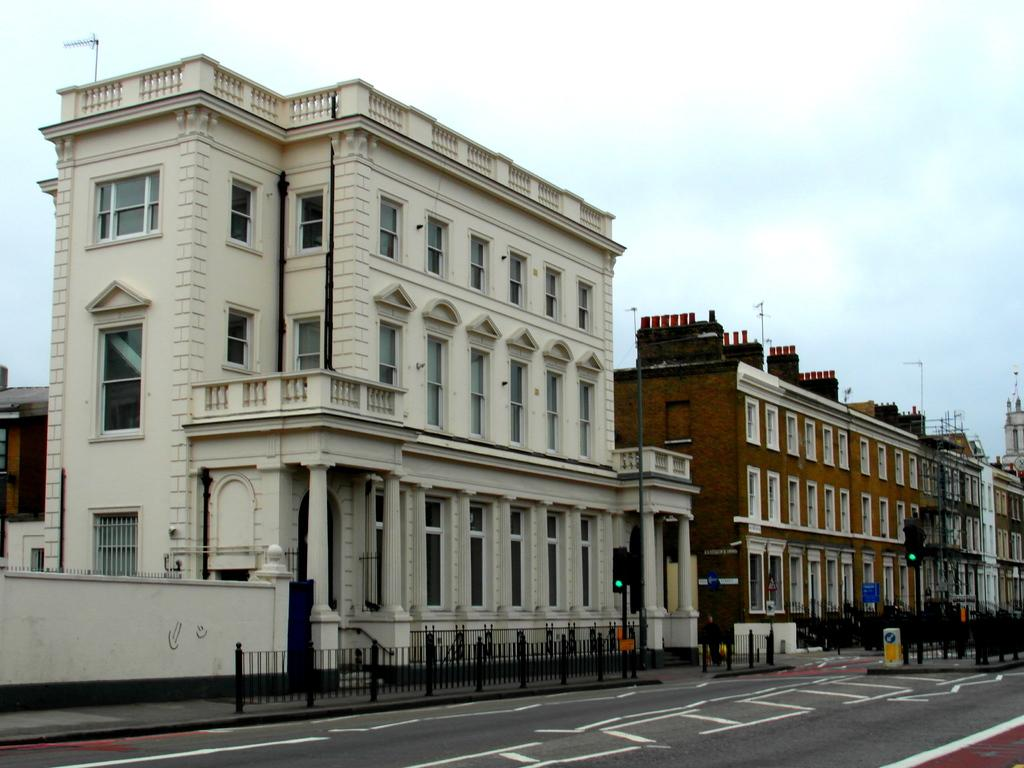What is the main feature of the image? There is a road in the image. What else can be seen alongside the road? There is a fence, traffic signal poles, boards, and buildings in the image. What is the purpose of the traffic signal poles? The traffic signal poles are used to regulate traffic flow. What can be seen in the background of the image? The sky is visible in the background of the image. Can you tell me what type of head the lawyer is wearing in the image? There is no lawyer or head present in the image; it features a road, a fence, traffic signal poles, boards, buildings, and the sky. What is the lawyer using the basin for in the image? There is no lawyer or basin present in the image. 